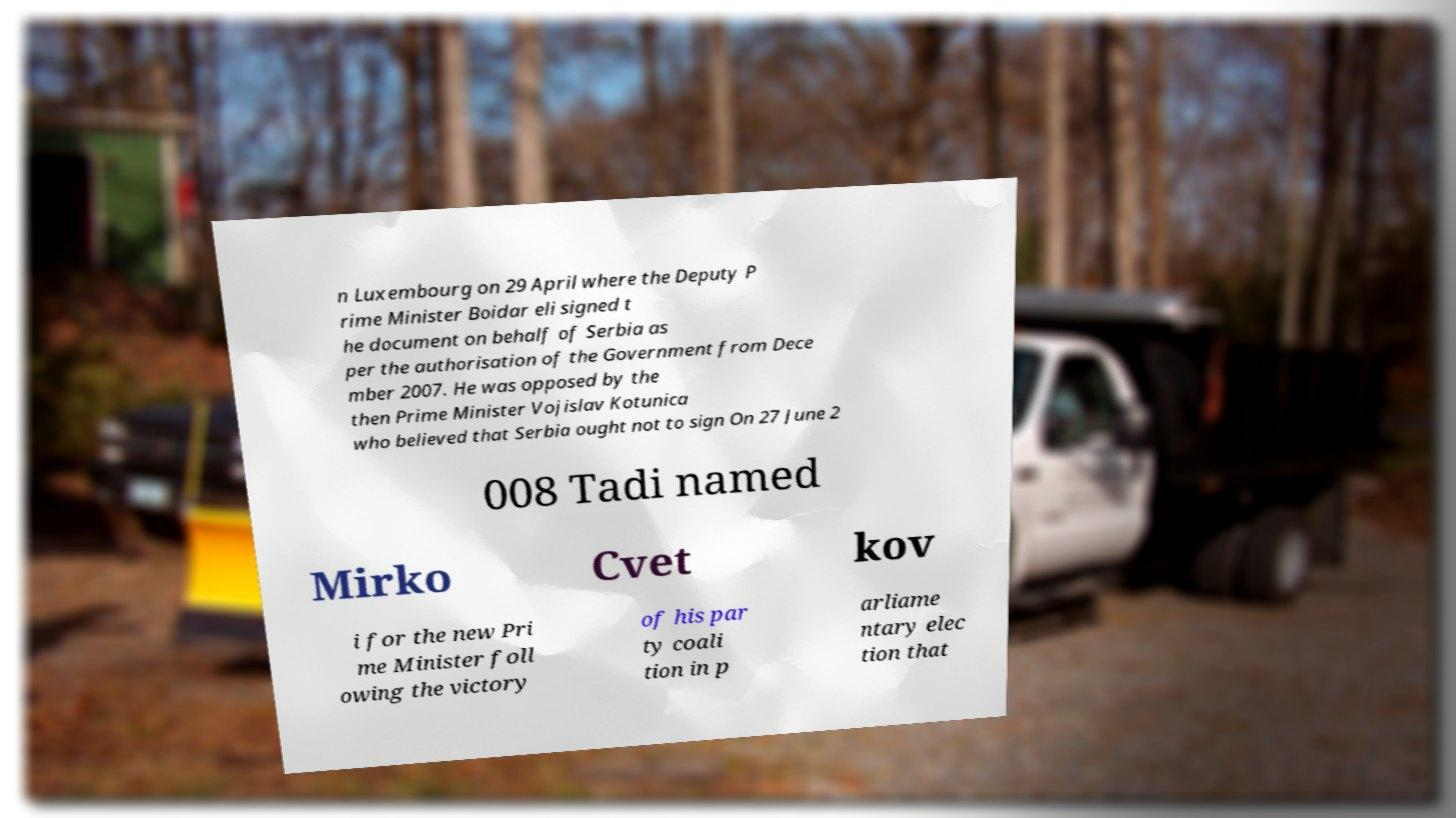I need the written content from this picture converted into text. Can you do that? n Luxembourg on 29 April where the Deputy P rime Minister Boidar eli signed t he document on behalf of Serbia as per the authorisation of the Government from Dece mber 2007. He was opposed by the then Prime Minister Vojislav Kotunica who believed that Serbia ought not to sign On 27 June 2 008 Tadi named Mirko Cvet kov i for the new Pri me Minister foll owing the victory of his par ty coali tion in p arliame ntary elec tion that 